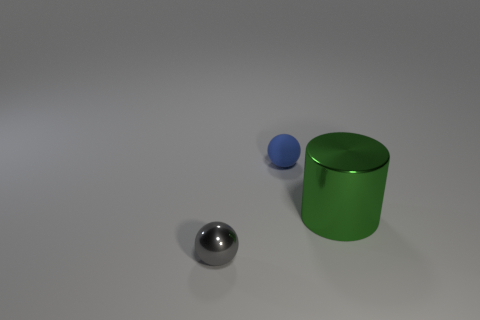How many things are large green things or metal objects that are behind the gray sphere?
Provide a short and direct response. 1. How many other objects are there of the same shape as the tiny matte object?
Provide a succinct answer. 1. Are there fewer tiny blue rubber spheres to the right of the large metal cylinder than tiny gray metal objects behind the rubber ball?
Your answer should be very brief. No. Is there any other thing that is the same material as the blue thing?
Provide a succinct answer. No. The thing that is made of the same material as the large cylinder is what shape?
Keep it short and to the point. Sphere. Is there any other thing of the same color as the matte sphere?
Offer a terse response. No. There is a metal object behind the small thing on the left side of the rubber ball; what is its color?
Offer a very short reply. Green. There is a large green cylinder that is behind the tiny object that is left of the thing that is behind the green metallic thing; what is it made of?
Provide a succinct answer. Metal. How many yellow rubber cubes have the same size as the gray metallic object?
Your response must be concise. 0. The thing that is in front of the small blue object and to the left of the metallic cylinder is made of what material?
Your answer should be very brief. Metal. 